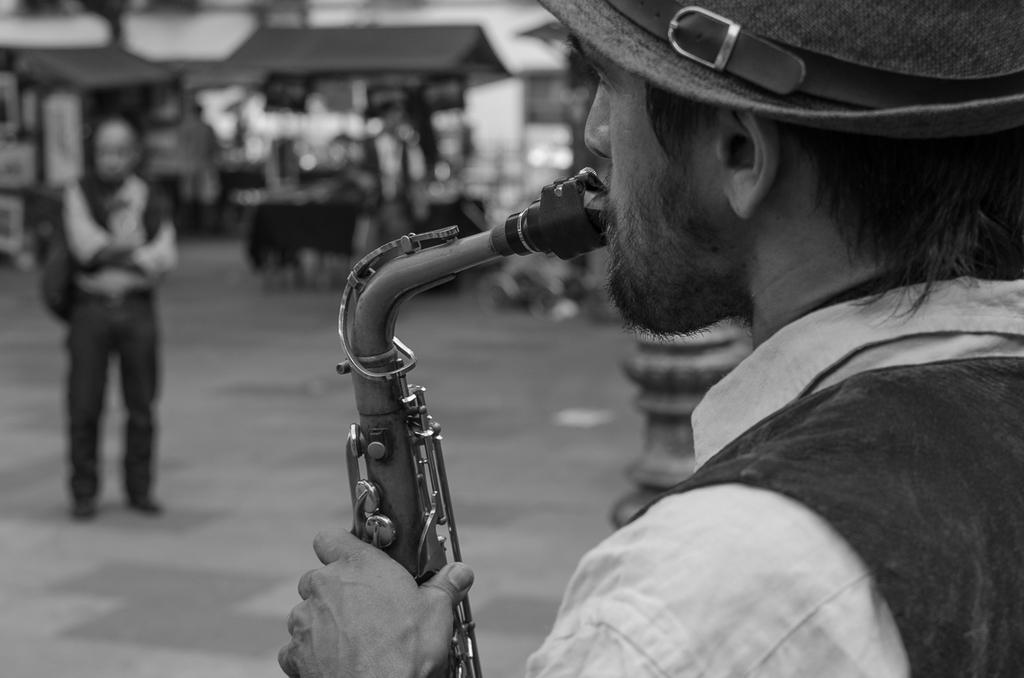What is the man in the image doing? The man is playing a musical instrument in the image. Where is the man located in the image? The man is in the front of the image. What can be seen in the center of the image? There is a person standing in the center of the image. How would you describe the background of the image? The background of the image is blurry. How many chickens are visible in the image? There are no chickens present in the image. What unit of measurement is used to determine the man's credit score in the image? There is no mention of credit scores or units of measurement in the image. 